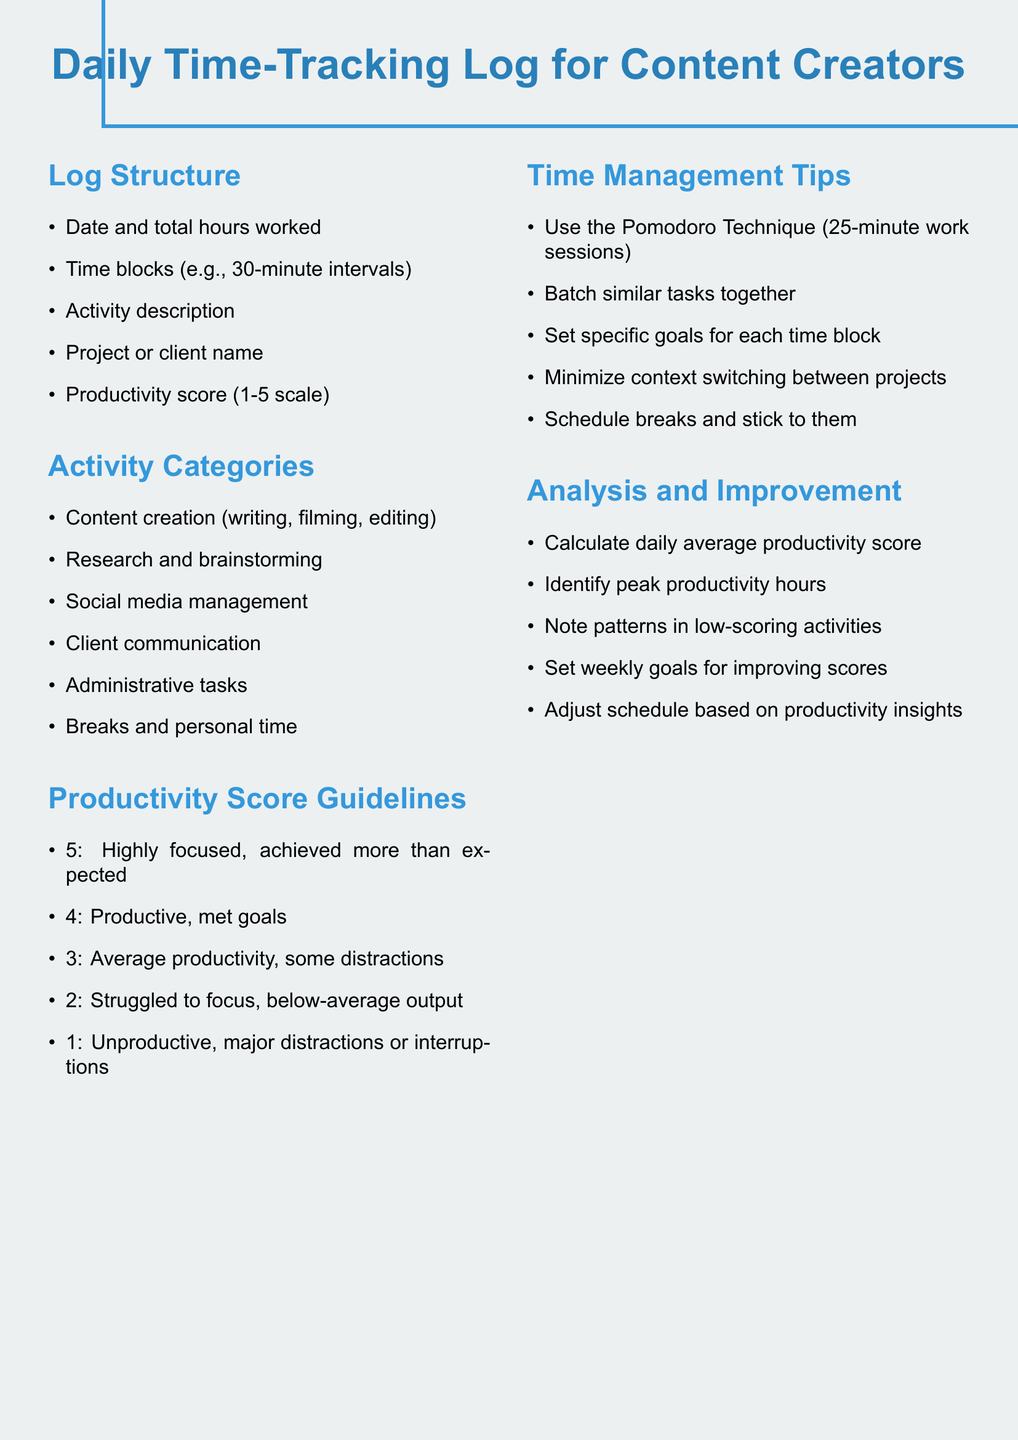What are the five sections in the document? The sections outline the log structure, activity categories, productivity score guidelines, time management tips, and analysis and improvement.
Answer: Log Structure, Activity Categories, Productivity Score Guidelines, Time Management Tips, Analysis and Improvement What is the highest productivity score? The productivity score guidelines list scores from 1 to 5, with 5 being the highest.
Answer: 5 What technique is suggested for time management? One of the tips for time management is the Pomodoro Technique, which consists of work sessions.
Answer: Pomodoro Technique Which activity category involves filming? Content creation involves writing, filming, and editing, making it the relevant category.
Answer: Content creation What is the productivity score for average productivity? According to the guidelines, an average productivity score corresponds to a score of 3 on the scale.
Answer: 3 How are low-scoring activities addressed in the document? The document suggests noting patterns in low-scoring activities as a way to analyze and improve productivity.
Answer: Note patterns in low-scoring activities What is one recommended action to minimize distractions? Scheduling breaks and adhering to them is recommended to maintain focus and minimize distractions.
Answer: Schedule breaks How is the daily average productivity score calculated? The document explicitly states to calculate the daily average productivity score as part of the analysis process.
Answer: Calculate daily average productivity score 